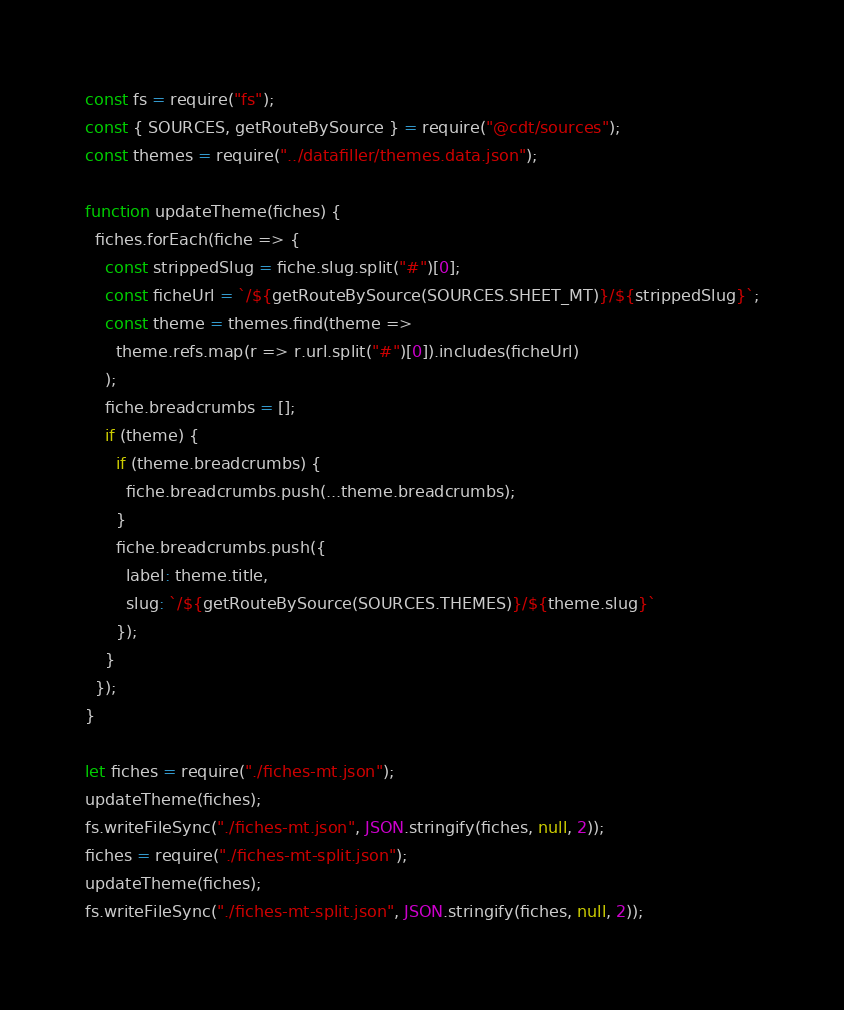Convert code to text. <code><loc_0><loc_0><loc_500><loc_500><_JavaScript_>const fs = require("fs");
const { SOURCES, getRouteBySource } = require("@cdt/sources");
const themes = require("../datafiller/themes.data.json");

function updateTheme(fiches) {
  fiches.forEach(fiche => {
    const strippedSlug = fiche.slug.split("#")[0];
    const ficheUrl = `/${getRouteBySource(SOURCES.SHEET_MT)}/${strippedSlug}`;
    const theme = themes.find(theme =>
      theme.refs.map(r => r.url.split("#")[0]).includes(ficheUrl)
    );
    fiche.breadcrumbs = [];
    if (theme) {
      if (theme.breadcrumbs) {
        fiche.breadcrumbs.push(...theme.breadcrumbs);
      }
      fiche.breadcrumbs.push({
        label: theme.title,
        slug: `/${getRouteBySource(SOURCES.THEMES)}/${theme.slug}`
      });
    }
  });
}

let fiches = require("./fiches-mt.json");
updateTheme(fiches);
fs.writeFileSync("./fiches-mt.json", JSON.stringify(fiches, null, 2));
fiches = require("./fiches-mt-split.json");
updateTheme(fiches);
fs.writeFileSync("./fiches-mt-split.json", JSON.stringify(fiches, null, 2));
</code> 